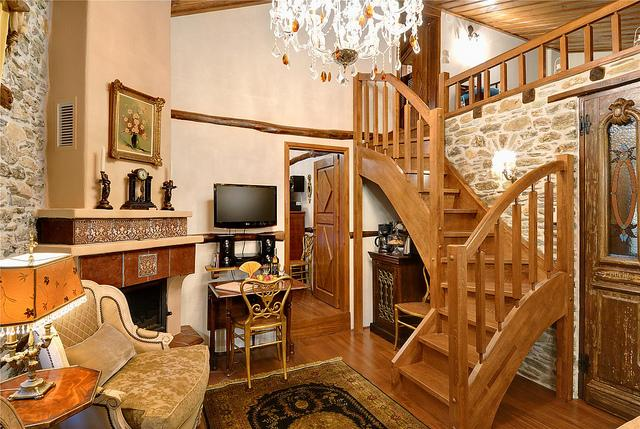What form of heating is used here? fireplace 